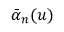<formula> <loc_0><loc_0><loc_500><loc_500>\bar { \alpha } _ { n } ( u )</formula> 